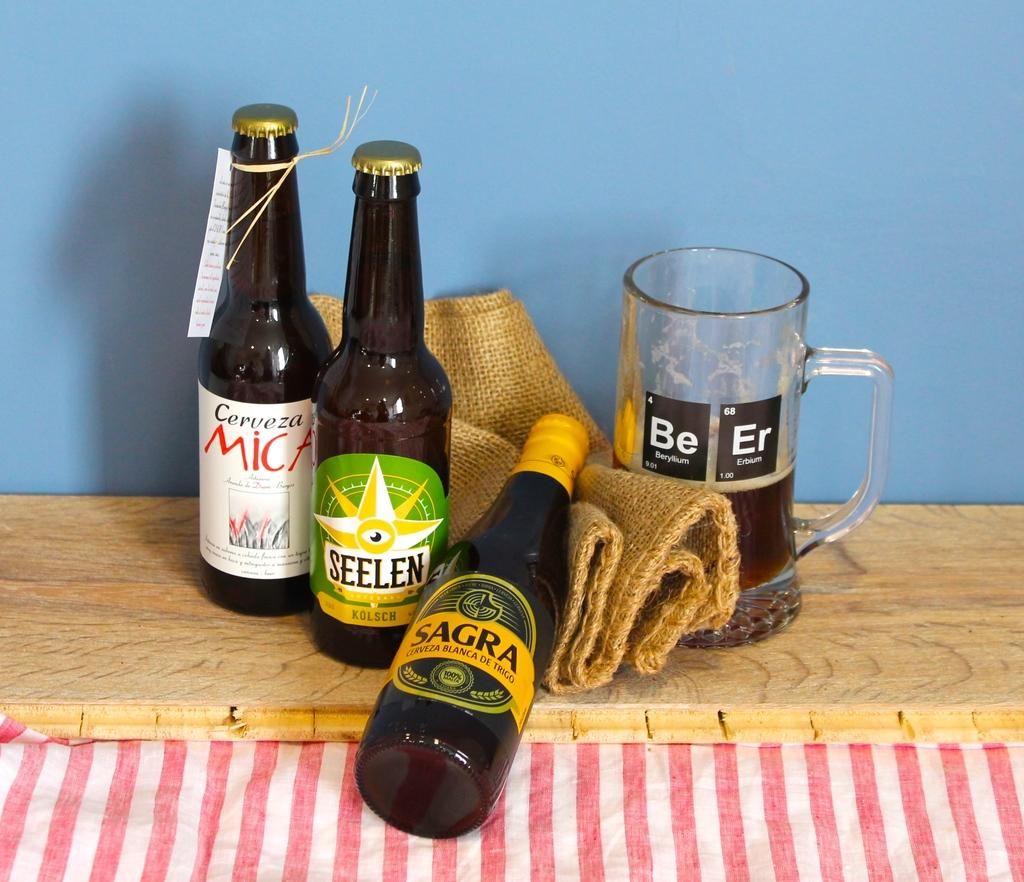<image>
Create a compact narrative representing the image presented. the word Mic is on the bottle of beer 